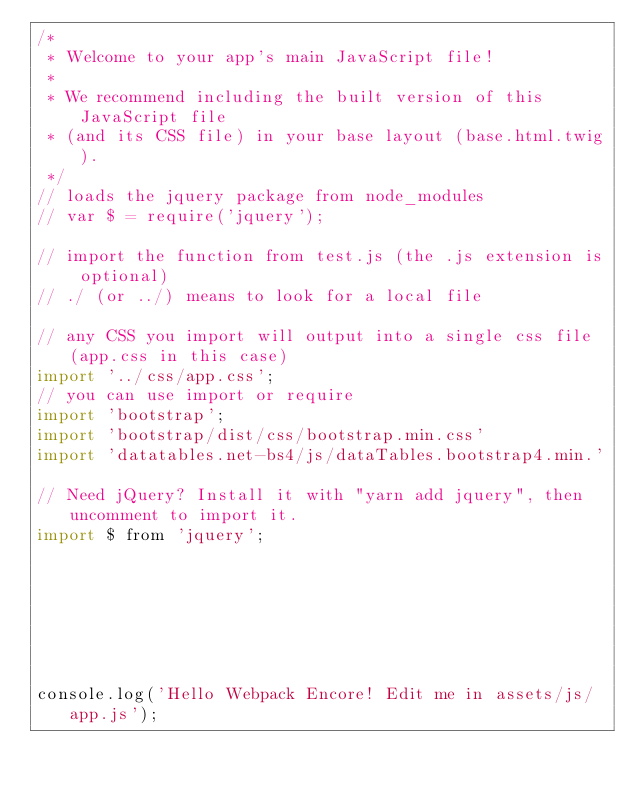<code> <loc_0><loc_0><loc_500><loc_500><_JavaScript_>/*
 * Welcome to your app's main JavaScript file!
 *
 * We recommend including the built version of this JavaScript file
 * (and its CSS file) in your base layout (base.html.twig).
 */
// loads the jquery package from node_modules
// var $ = require('jquery');

// import the function from test.js (the .js extension is optional)
// ./ (or ../) means to look for a local file

// any CSS you import will output into a single css file (app.css in this case)
import '../css/app.css';
// you can use import or require
import 'bootstrap';
import 'bootstrap/dist/css/bootstrap.min.css'
import 'datatables.net-bs4/js/dataTables.bootstrap4.min.'

// Need jQuery? Install it with "yarn add jquery", then uncomment to import it.
import $ from 'jquery';







console.log('Hello Webpack Encore! Edit me in assets/js/app.js');</code> 